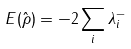<formula> <loc_0><loc_0><loc_500><loc_500>E ( \hat { \rho } ) = - 2 \sum _ { i } \lambda ^ { - } _ { i }</formula> 